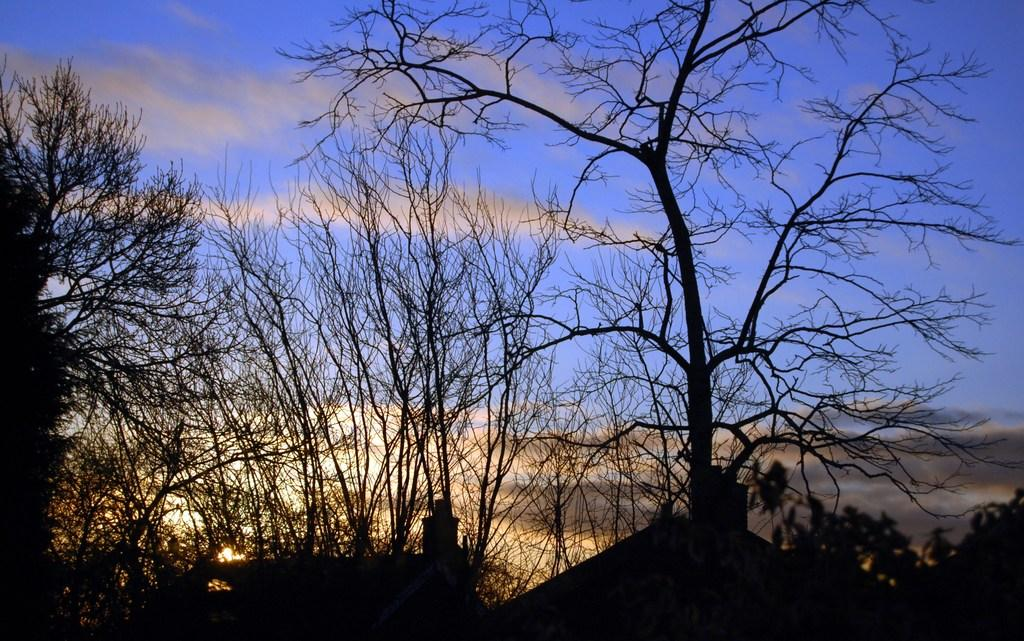What type of structures can be seen in the image? There are houses in the image. What other natural elements are present in the image? There are many trees in the image. What part of the natural environment is visible in the image? The sky is visible in the image. What can be observed in the sky? Clouds are present in the sky. What type of development is taking place in the image? There is no specific development mentioned or visible in the image. 